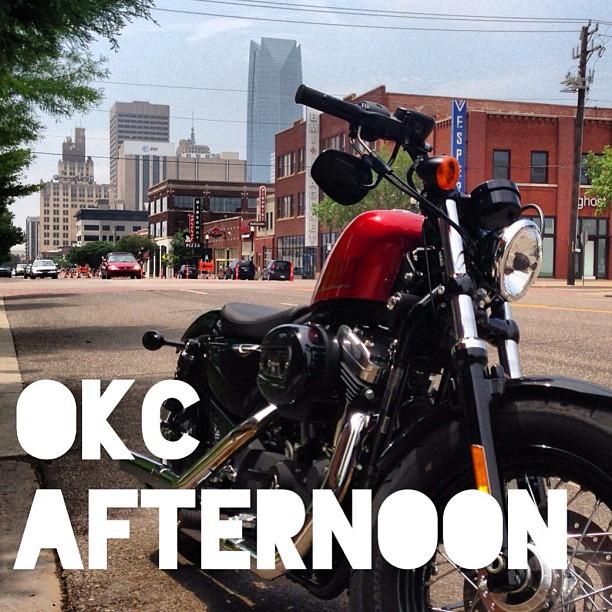What color is the motorcycle?
Be succinct. Red. What city is this in?
Short answer required. Oklahoma city. How much does the motorcycle cost?
Write a very short answer. Lot. 